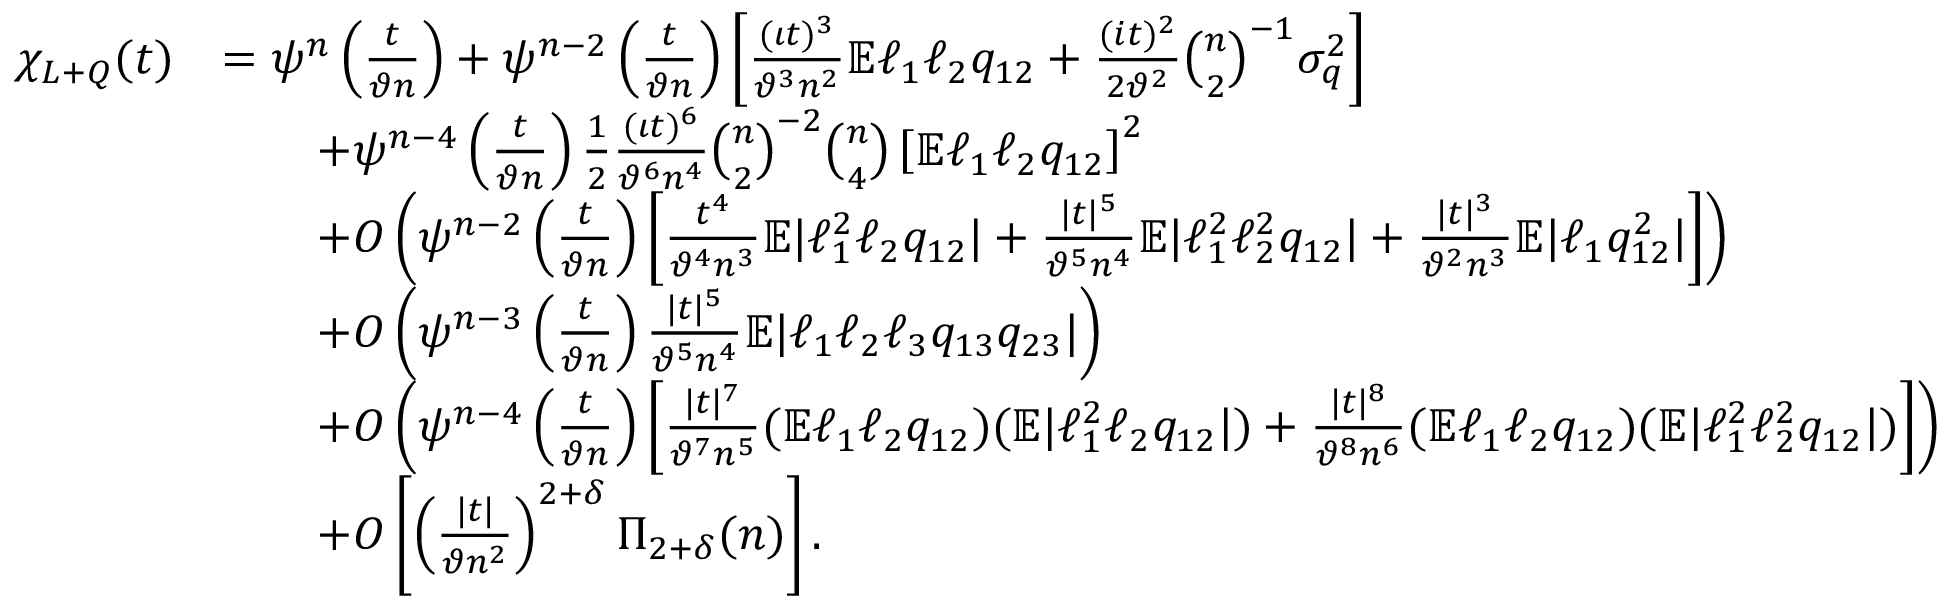Convert formula to latex. <formula><loc_0><loc_0><loc_500><loc_500>\begin{array} { r l } { \chi _ { L + Q } ( t ) } & { = \psi ^ { n } \left ( \frac { t } { \vartheta n } \right ) + \psi ^ { n - 2 } \left ( \frac { t } { \vartheta n } \right ) \left [ \frac { ( \iota t ) ^ { 3 } } { \vartheta ^ { 3 } n ^ { 2 } } \mathbb { E } \ell _ { 1 } \ell _ { 2 } q _ { 1 2 } + \frac { ( i t ) ^ { 2 } } { 2 \vartheta ^ { 2 } } \binom { n } { 2 } ^ { - 1 } \sigma _ { q } ^ { 2 } \right ] } \\ & { \quad + \psi ^ { n - 4 } \left ( \frac { t } { \vartheta n } \right ) \frac { 1 } { 2 } \frac { ( \iota t ) ^ { 6 } } { \vartheta ^ { 6 } n ^ { 4 } } \binom { n } { 2 } ^ { - 2 } \binom { n } { 4 } \left [ \mathbb { E } \ell _ { 1 } \ell _ { 2 } q _ { 1 2 } \right ] ^ { 2 } } \\ & { \quad + O \left ( \psi ^ { n - 2 } \left ( \frac { t } { \vartheta n } \right ) \left [ \frac { t ^ { 4 } } { \vartheta ^ { 4 } n ^ { 3 } } \mathbb { E } | \ell _ { 1 } ^ { 2 } \ell _ { 2 } q _ { 1 2 } | + \frac { | t | ^ { 5 } } { \vartheta ^ { 5 } n ^ { 4 } } \mathbb { E } | \ell _ { 1 } ^ { 2 } \ell _ { 2 } ^ { 2 } q _ { 1 2 } | + \frac { | t | ^ { 3 } } { \vartheta ^ { 2 } n ^ { 3 } } \mathbb { E } | \ell _ { 1 } q _ { 1 2 } ^ { 2 } | \right ] \right ) } \\ & { \quad + O \left ( \psi ^ { n - 3 } \left ( \frac { t } { \vartheta n } \right ) \frac { | t | ^ { 5 } } { \vartheta ^ { 5 } n ^ { 4 } } \mathbb { E } | \ell _ { 1 } \ell _ { 2 } \ell _ { 3 } q _ { 1 3 } q _ { 2 3 } | \right ) } \\ & { \quad + O \left ( \psi ^ { n - 4 } \left ( \frac { t } { \vartheta n } \right ) \left [ \frac { | t | ^ { 7 } } { \vartheta ^ { 7 } n ^ { 5 } } ( \mathbb { E } \ell _ { 1 } \ell _ { 2 } q _ { 1 2 } ) ( \mathbb { E } | \ell _ { 1 } ^ { 2 } \ell _ { 2 } q _ { 1 2 } | ) + \frac { | t | ^ { 8 } } { \vartheta ^ { 8 } n ^ { 6 } } ( \mathbb { E } \ell _ { 1 } \ell _ { 2 } q _ { 1 2 } ) ( \mathbb { E } | \ell _ { 1 } ^ { 2 } \ell _ { 2 } ^ { 2 } q _ { 1 2 } | ) \right ] \right ) } \\ & { \quad + O \left [ \left ( \frac { | t | } { \vartheta n ^ { 2 } } \right ) ^ { 2 + \delta } \Pi _ { 2 + \delta } ( n ) \right ] . } \end{array}</formula> 